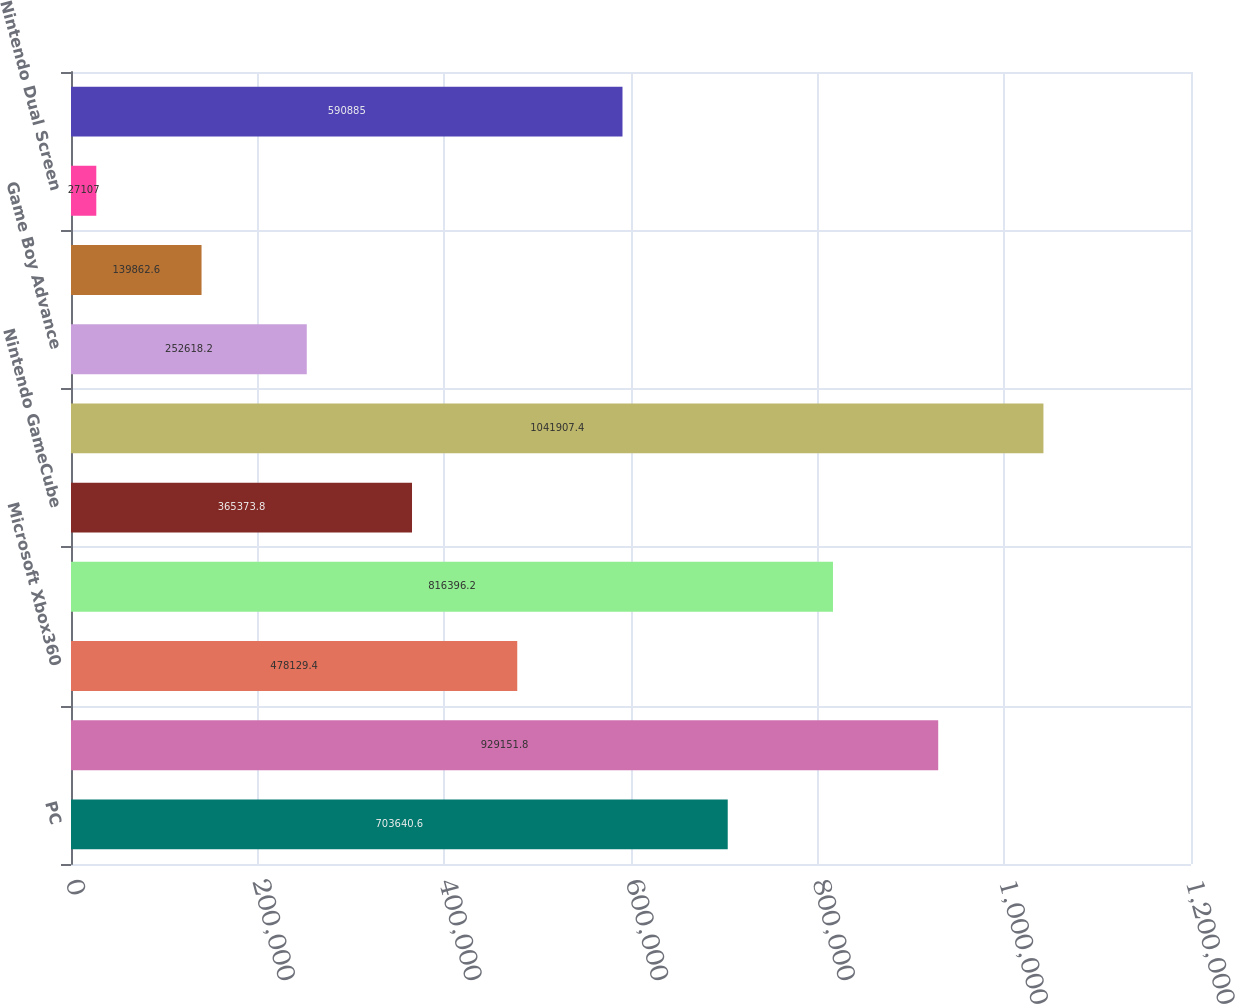Convert chart to OTSL. <chart><loc_0><loc_0><loc_500><loc_500><bar_chart><fcel>PC<fcel>Sony PlayStation 2<fcel>Microsoft Xbox360<fcel>Microsoft Xbox<fcel>Nintendo GameCube<fcel>Total console<fcel>Game Boy Advance<fcel>PlayStation Portable<fcel>Nintendo Dual Screen<fcel>Total hand-held<nl><fcel>703641<fcel>929152<fcel>478129<fcel>816396<fcel>365374<fcel>1.04191e+06<fcel>252618<fcel>139863<fcel>27107<fcel>590885<nl></chart> 